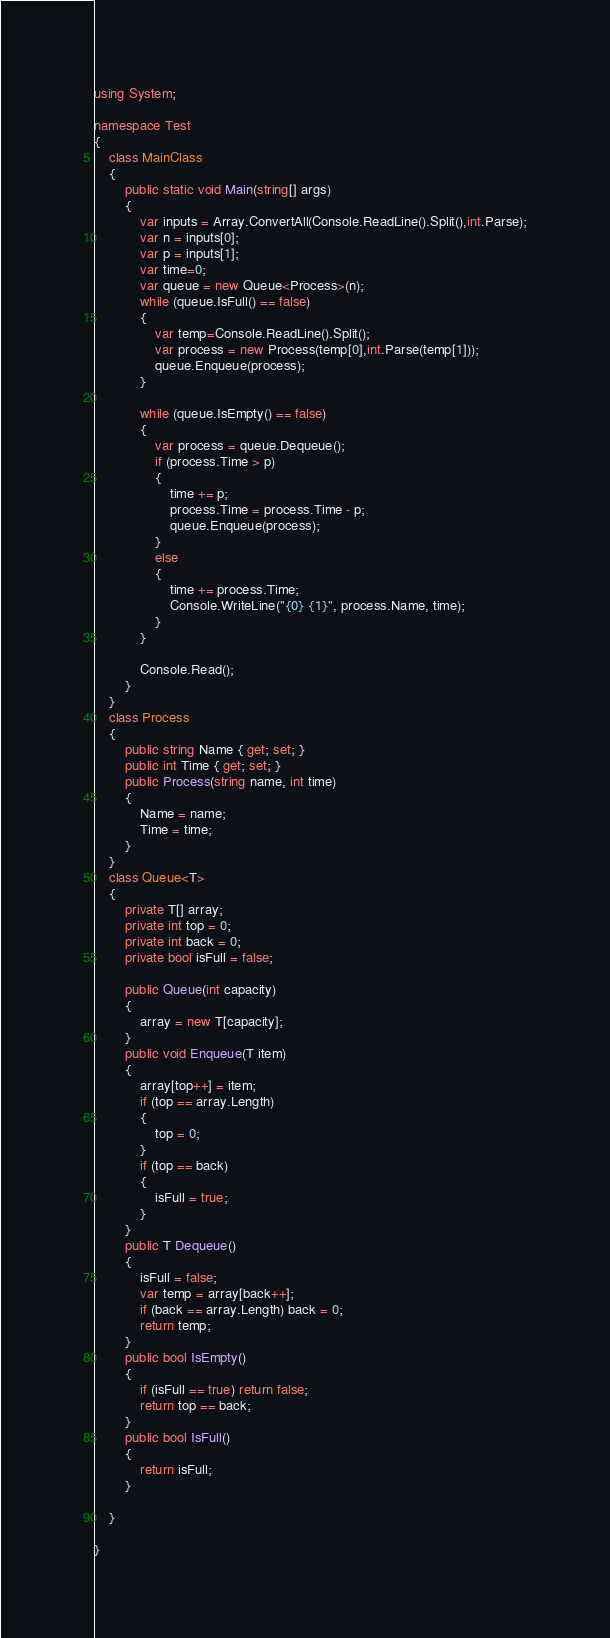Convert code to text. <code><loc_0><loc_0><loc_500><loc_500><_C#_>using System;

namespace Test
{
    class MainClass
    {
        public static void Main(string[] args)
        {
            var inputs = Array.ConvertAll(Console.ReadLine().Split(),int.Parse);
            var n = inputs[0];
            var p = inputs[1];
            var time=0;
            var queue = new Queue<Process>(n);
            while (queue.IsFull() == false)
            {
                var temp=Console.ReadLine().Split();
                var process = new Process(temp[0],int.Parse(temp[1]));
                queue.Enqueue(process);
            }

            while (queue.IsEmpty() == false)
            {
                var process = queue.Dequeue();
                if (process.Time > p)
                {
                    time += p;
                    process.Time = process.Time - p;
                    queue.Enqueue(process);
                }
                else
                {
                    time += process.Time;
                    Console.WriteLine("{0} {1}", process.Name, time);
                }
            }

            Console.Read();
        }
    }
    class Process
    {
        public string Name { get; set; }
        public int Time { get; set; }
        public Process(string name, int time)
        {
            Name = name;
            Time = time;
        }
    }
    class Queue<T>
    {
        private T[] array;
        private int top = 0;
        private int back = 0;
        private bool isFull = false;

        public Queue(int capacity)
        {
            array = new T[capacity];
        }
        public void Enqueue(T item)
        {
            array[top++] = item;
            if (top == array.Length)
            {
                top = 0;
            }
            if (top == back)
            {
                isFull = true;
            }
        }
        public T Dequeue()
        {
            isFull = false;
            var temp = array[back++];
            if (back == array.Length) back = 0;
            return temp;
        }
        public bool IsEmpty()
        {
            if (isFull == true) return false;
            return top == back;
        }
        public bool IsFull()
        {
            return isFull;
        }
        
    }

}</code> 